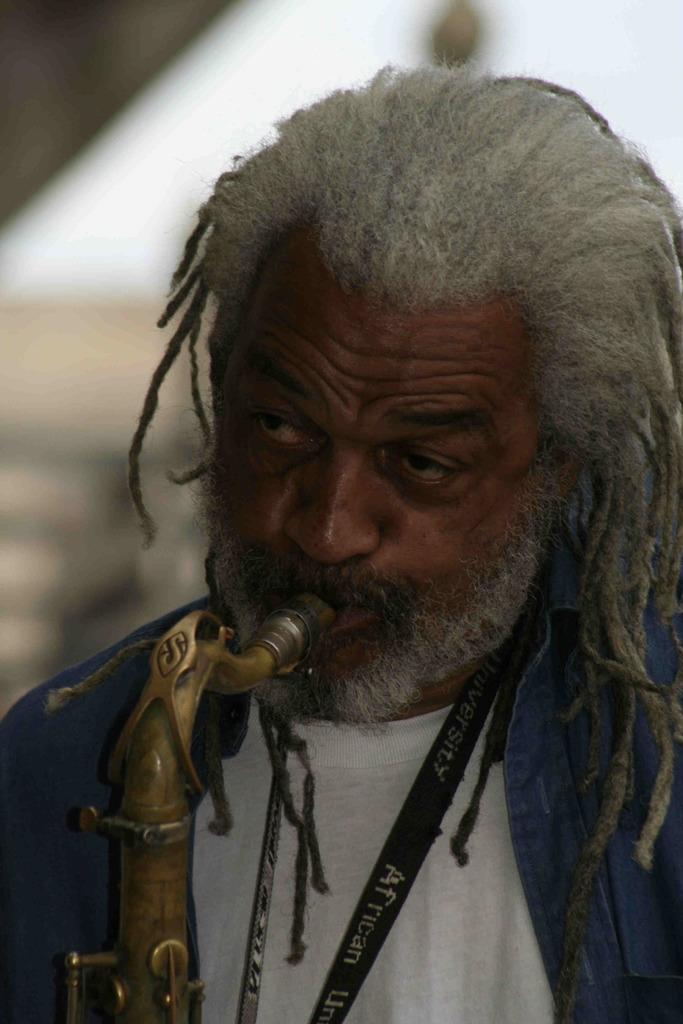What is present in the image? There is a person in the image. What is the person doing in the image? The person has an object in their mouth. Can you describe the background of the image? The background of the image is blurry. How many mint leaves can be seen on the beds in the image? There are no mint leaves or beds present in the image. 